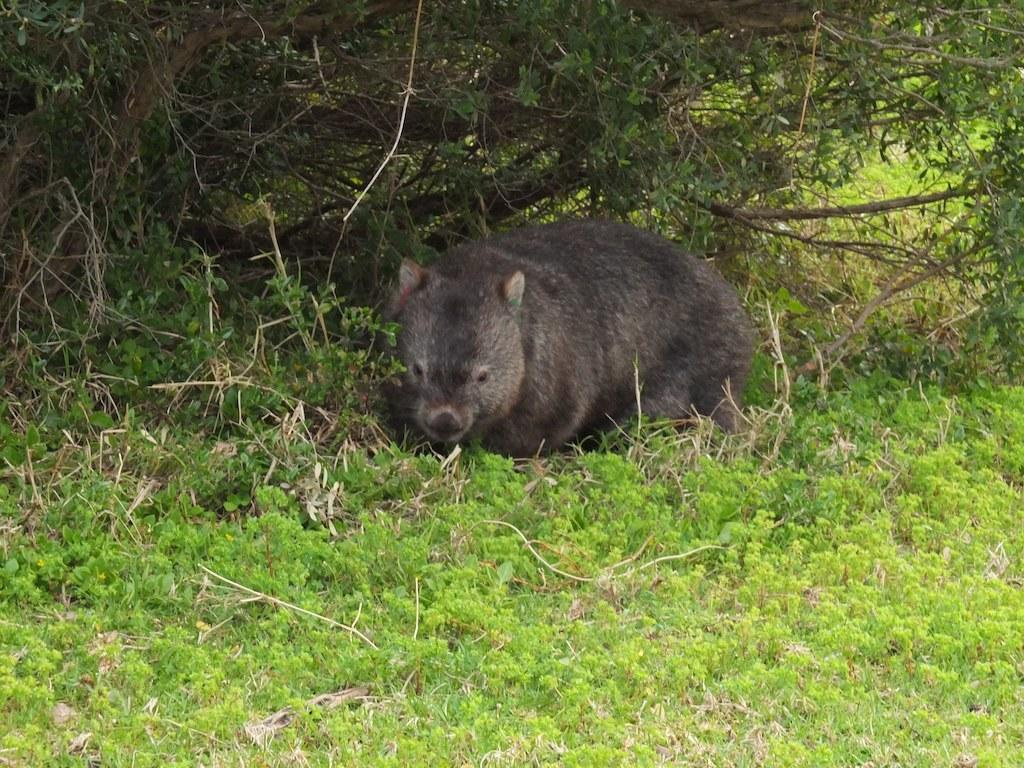What type of animal can be seen in the image? There is an animal in the image, but its specific breed or species is not mentioned in the facts. What colors are present on the animal? The animal is cream and black in color. Where is the animal located in the image? The animal is on the ground. What type of vegetation is visible in the image? There is green grass in the image. What else can be seen in the background of the image? There are trees in the image. What type of invention can be seen in the animal's hand in the image? There is no invention present in the image, nor is there any indication that the animal has hands. 